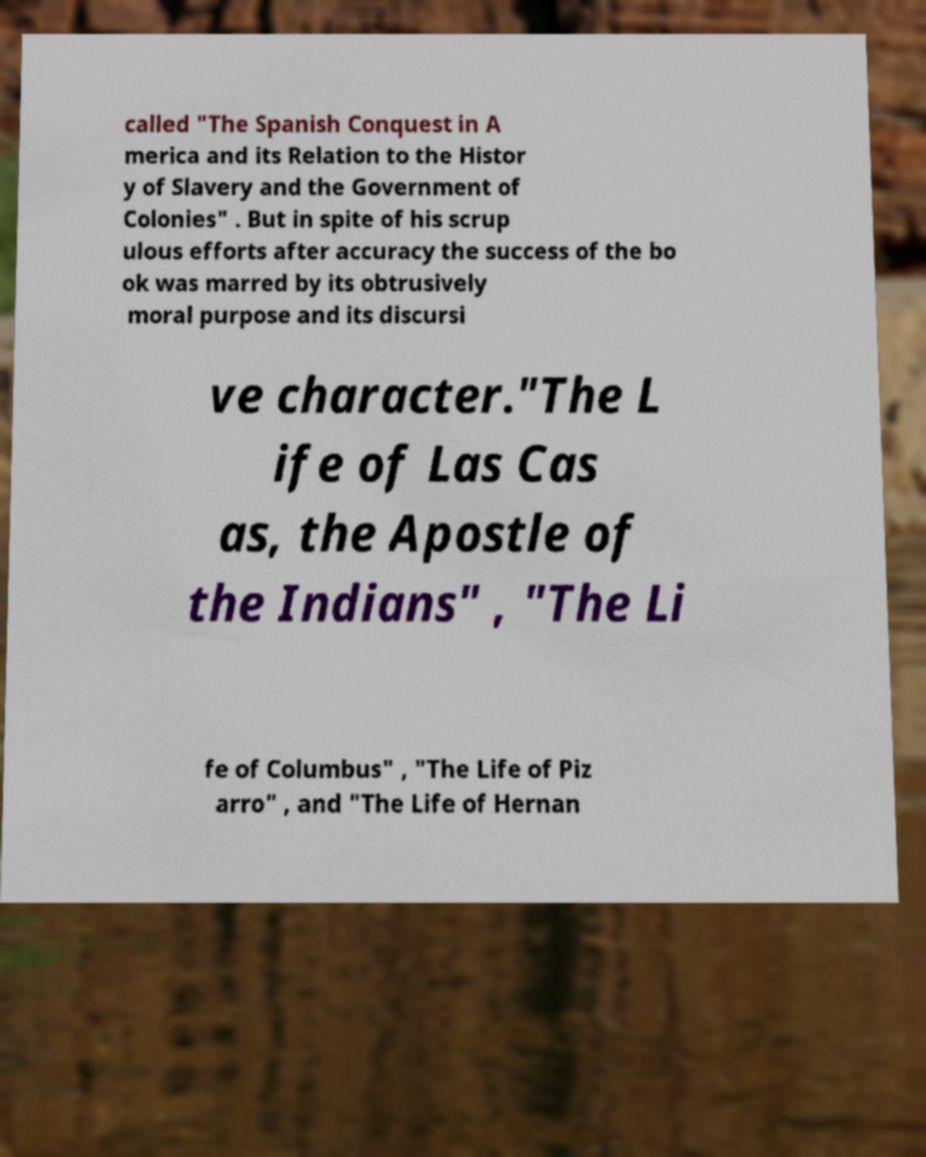There's text embedded in this image that I need extracted. Can you transcribe it verbatim? called "The Spanish Conquest in A merica and its Relation to the Histor y of Slavery and the Government of Colonies" . But in spite of his scrup ulous efforts after accuracy the success of the bo ok was marred by its obtrusively moral purpose and its discursi ve character."The L ife of Las Cas as, the Apostle of the Indians" , "The Li fe of Columbus" , "The Life of Piz arro" , and "The Life of Hernan 